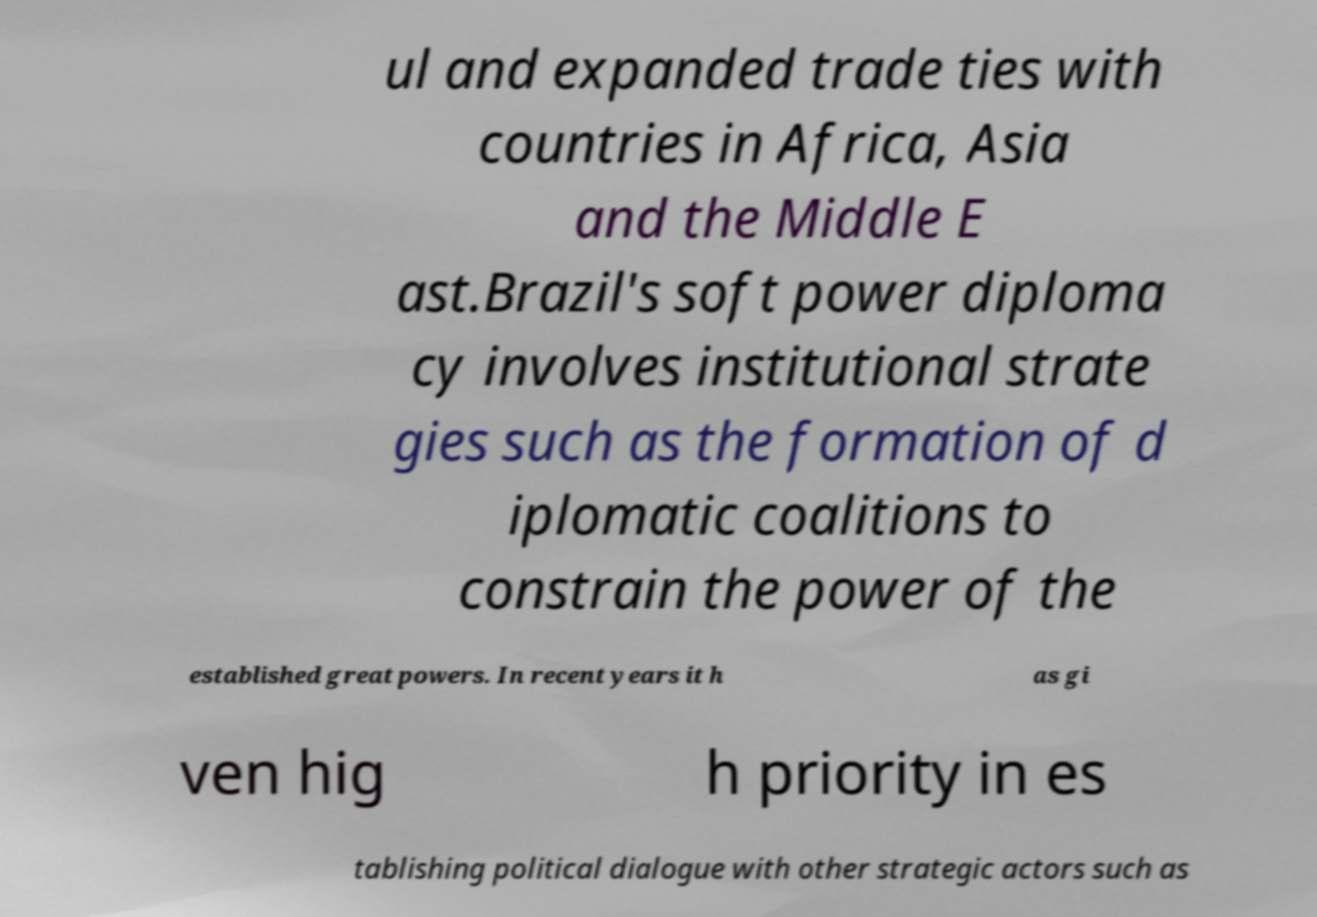There's text embedded in this image that I need extracted. Can you transcribe it verbatim? ul and expanded trade ties with countries in Africa, Asia and the Middle E ast.Brazil's soft power diploma cy involves institutional strate gies such as the formation of d iplomatic coalitions to constrain the power of the established great powers. In recent years it h as gi ven hig h priority in es tablishing political dialogue with other strategic actors such as 